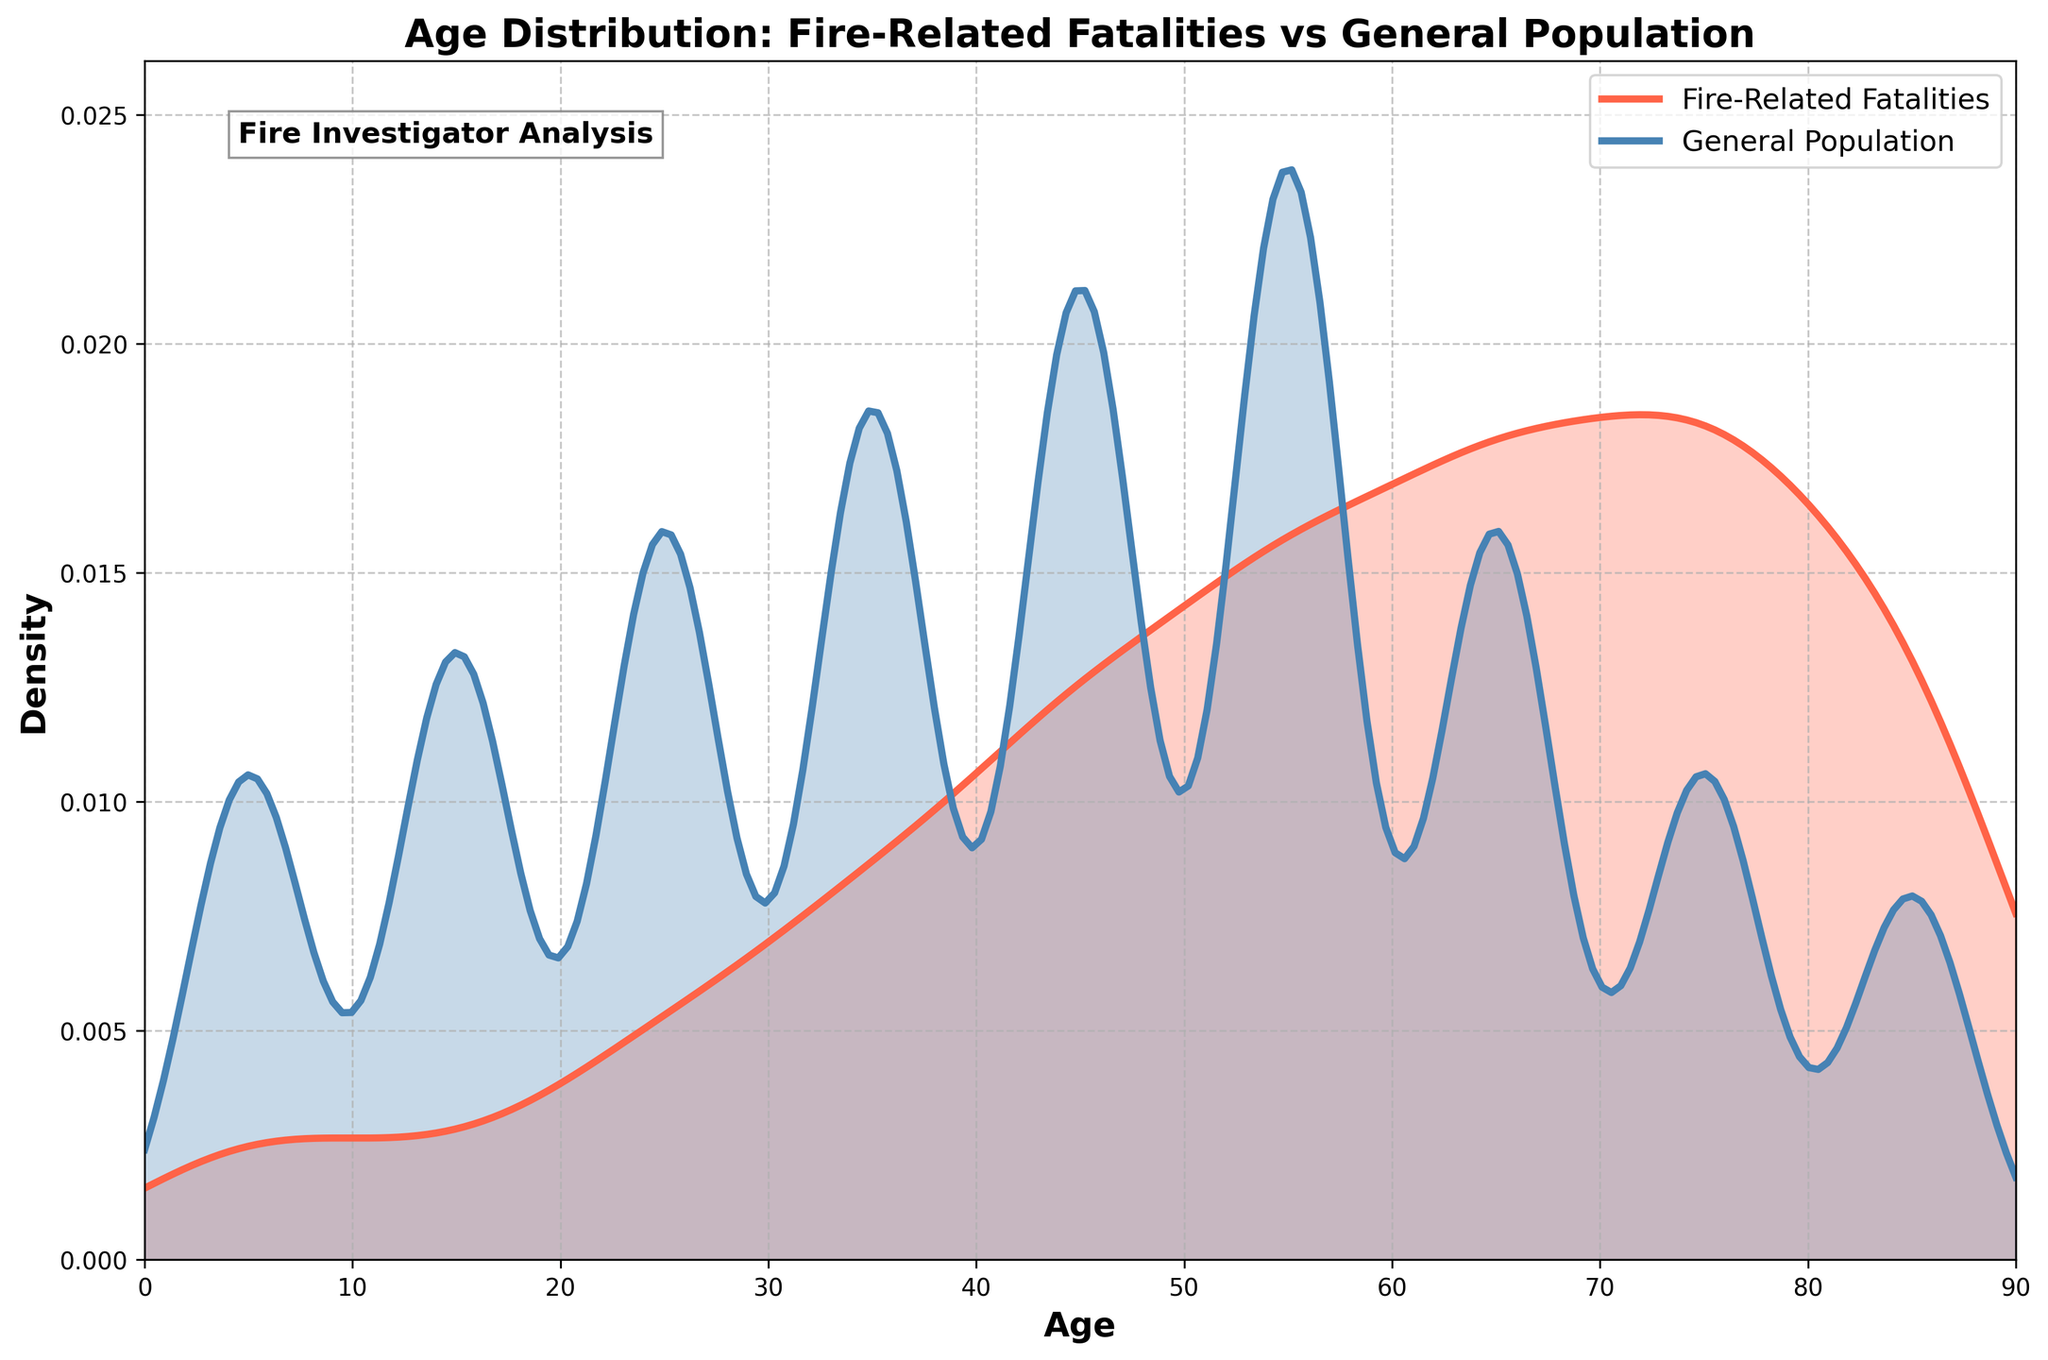What are the colors used to represent "Fire-Related Fatalities" and "General Population" in the plot? The plot uses a red color to represent "Fire-Related Fatalities" and a blue color to represent the "General Population."
Answer: Red and Blue What is the overall trend in the density curve for fire-related fatalities as age increases? As age increases, the density of fire-related fatalities increases steadily, peaking around the 70-80 age range, and then decreases in the 80+ range.
Answer: Increases, peaks at 70-80, then decreases How does the density of the general population compare to the density of fire-related fatalities in the 50-60 age range? The density of the general population is higher than that of fire-related fatalities in the 50-60 age range, which suggests that a smaller proportion of the general population in this age range experiences fire-related fatalities compared to other age ranges.
Answer: Higher Where does the density curve for fire-related fatalities peak? The density curve for fire-related fatalities peaks around the 70-80 age range.
Answer: 70-80 age range What is indicated by filling the areas under the density curves in the plot? The filled areas under the density curves indicate the distribution of the age groups within the fire-related fatalities and the general population groups. It visually conveys the concentration and spread of data in each category.
Answer: Distribution of age groups Which age range has the highest density for fire-related fatalities? The age range 70-80 has the highest density for fire-related fatalities, as indicated by the peak in the density curve.
Answer: 70-80 Between the age ranges 20-30 and 40-50, which one has a higher density of fire-related fatalities? The age range 40-50 has a higher density of fire-related fatalities compared to the 20-30 age range, as seen in the steeper rise in the density plot for the former.
Answer: 40-50 In which age ranges does the density of fire-related fatalities exceed that of the general population? The density of fire-related fatalities exceeds that of the general population in the age ranges 60-70, 70-80, and 80+. This is indicated by the higher density curve for fire-related fatalities in these ranges.
Answer: 60-70, 70-80, 80+ How does the plot visually indicate that it is analyzing fire-related fatalities? The title "Age Distribution: Fire-Related Fatalities vs General Population" and the colors assigned to the density curves make it clear that fire-related fatalities are being analyzed in comparison to the general population.
Answer: Title and colors What can be inferred about fire safety measures from the age group showing the highest fire-related fatalities? Given that the age group 70-80 has the highest fire-related fatalities, it suggests that fire safety measures may need to be intensified for the elderly population to address their higher vulnerability.
Answer: Intensify for elderly 